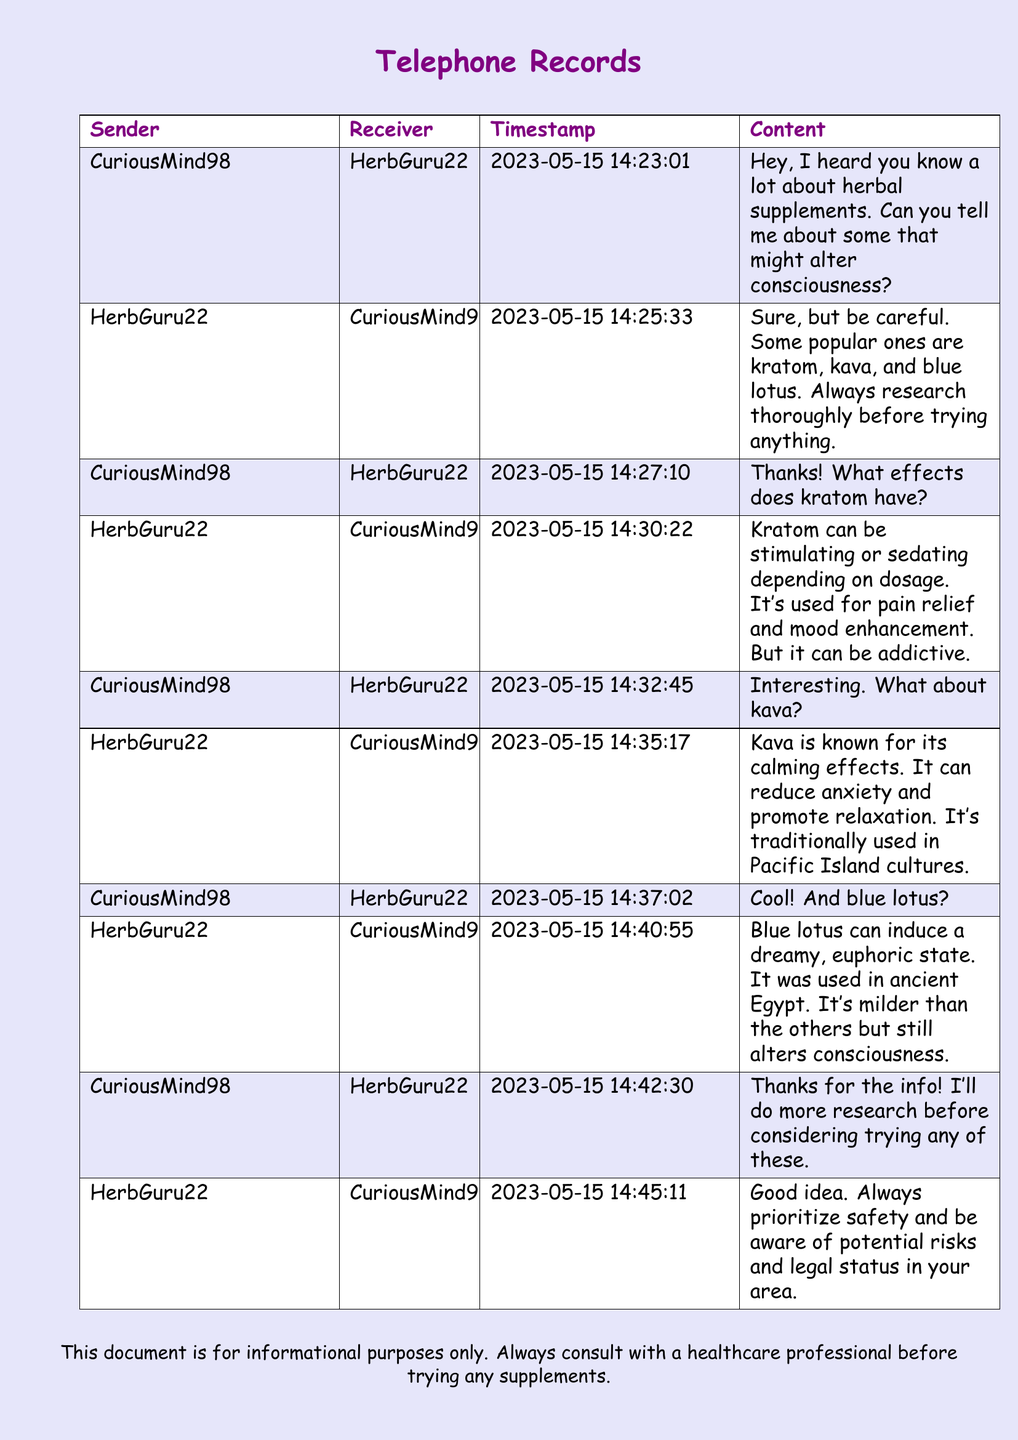What are some herbal supplements mentioned? The document lists kratom, kava, and blue lotus as herbal supplements.
Answer: kratom, kava, blue lotus Who sent the first message? The first message is from CuriousMind98 to HerbGuru22.
Answer: CuriousMind98 What is the timestamp for the message about blue lotus? The timestamp for the blue lotus message is when HerbGuru22 replied about its effects.
Answer: 2023-05-15 14:40:55 What can kava reduce? Kava is known to reduce anxiety according to the document.
Answer: anxiety What effect can kratom have depending on dosage? The document states that kratom can be stimulating or sedating.
Answer: stimulating or sedating What is the traditional use of kava? Kava is used traditionally in Pacific Island cultures for calming effects.
Answer: calming effects What does HerbGuru22 advise at the end of the conversation? HerbGuru22 advises prioritizing safety and being aware of potential risks.
Answer: safety and potential risks How long is the conversation? The conversation spans from 2023-05-15 14:23:01 to 2023-05-15 14:45:11.
Answer: 22 minutes 10 seconds 